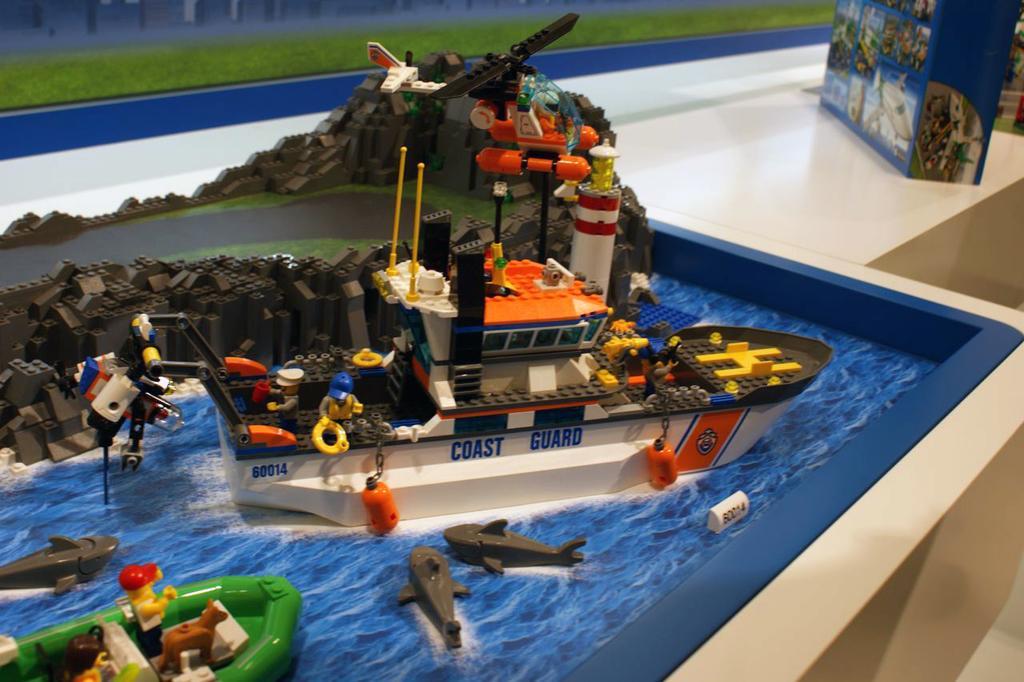How would you summarize this image in a sentence or two? In this image there are few toy persons in the toy ships and boats, which are on the toy river, above that there is a toy airplane, beside that there is a cover box of the toy placed on the table. 